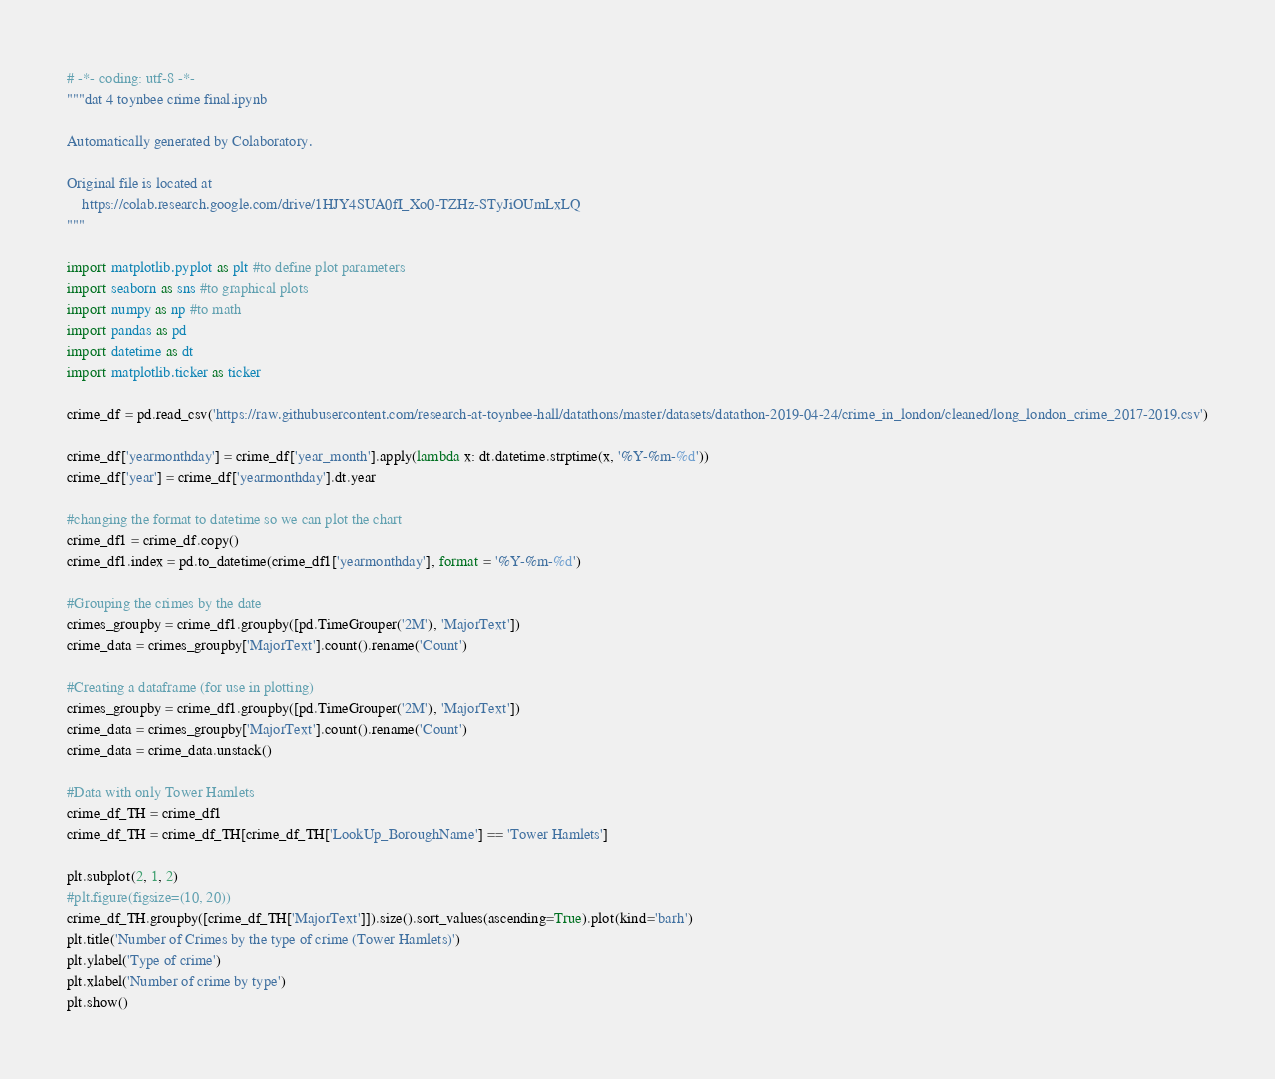<code> <loc_0><loc_0><loc_500><loc_500><_Python_># -*- coding: utf-8 -*-
"""dat 4 toynbee crime final.ipynb

Automatically generated by Colaboratory.

Original file is located at
    https://colab.research.google.com/drive/1HJY4SUA0fI_Xo0-TZHz-STyJiOUmLxLQ
"""

import matplotlib.pyplot as plt #to define plot parameters
import seaborn as sns #to graphical plots
import numpy as np #to math
import pandas as pd
import datetime as dt
import matplotlib.ticker as ticker

crime_df = pd.read_csv('https://raw.githubusercontent.com/research-at-toynbee-hall/datathons/master/datasets/datathon-2019-04-24/crime_in_london/cleaned/long_london_crime_2017-2019.csv')

crime_df['yearmonthday'] = crime_df['year_month'].apply(lambda x: dt.datetime.strptime(x, '%Y-%m-%d'))
crime_df['year'] = crime_df['yearmonthday'].dt.year

#changing the format to datetime so we can plot the chart
crime_df1 = crime_df.copy()
crime_df1.index = pd.to_datetime(crime_df1['yearmonthday'], format = '%Y-%m-%d')

#Grouping the crimes by the date
crimes_groupby = crime_df1.groupby([pd.TimeGrouper('2M'), 'MajorText'])
crime_data = crimes_groupby['MajorText'].count().rename('Count')

#Creating a dataframe (for use in plotting) 
crimes_groupby = crime_df1.groupby([pd.TimeGrouper('2M'), 'MajorText'])
crime_data = crimes_groupby['MajorText'].count().rename('Count')
crime_data = crime_data.unstack()

#Data with only Tower Hamlets
crime_df_TH = crime_df1
crime_df_TH = crime_df_TH[crime_df_TH['LookUp_BoroughName'] == 'Tower Hamlets']

plt.subplot(2, 1, 2)
#plt.figure(figsize=(10, 20))
crime_df_TH.groupby([crime_df_TH['MajorText']]).size().sort_values(ascending=True).plot(kind='barh')
plt.title('Number of Crimes by the type of crime (Tower Hamlets)')
plt.ylabel('Type of crime')
plt.xlabel('Number of crime by type')
plt.show()
</code> 